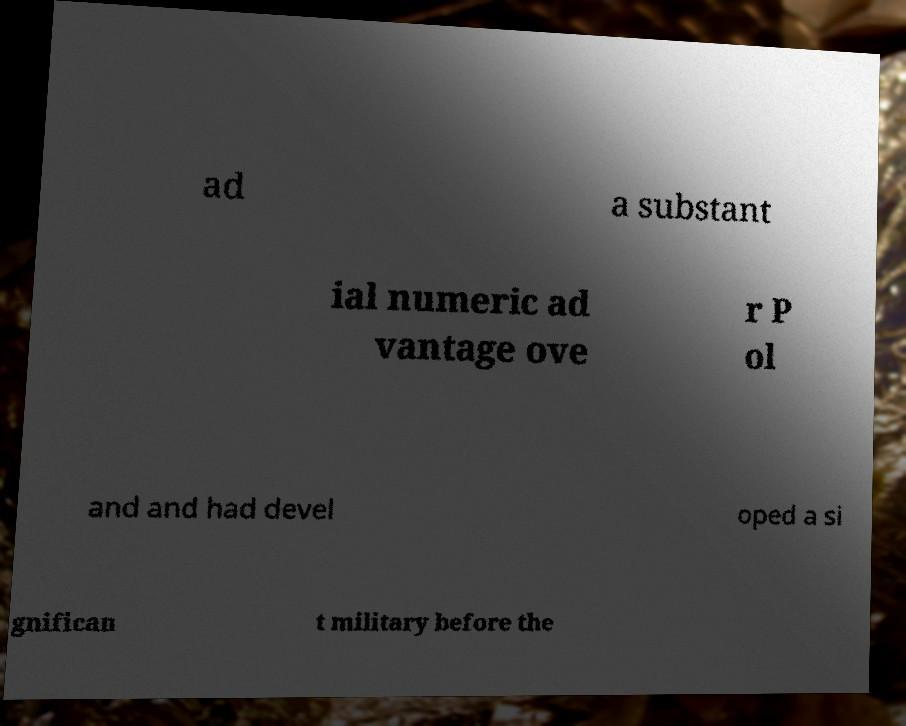What messages or text are displayed in this image? I need them in a readable, typed format. ad a substant ial numeric ad vantage ove r P ol and and had devel oped a si gnifican t military before the 